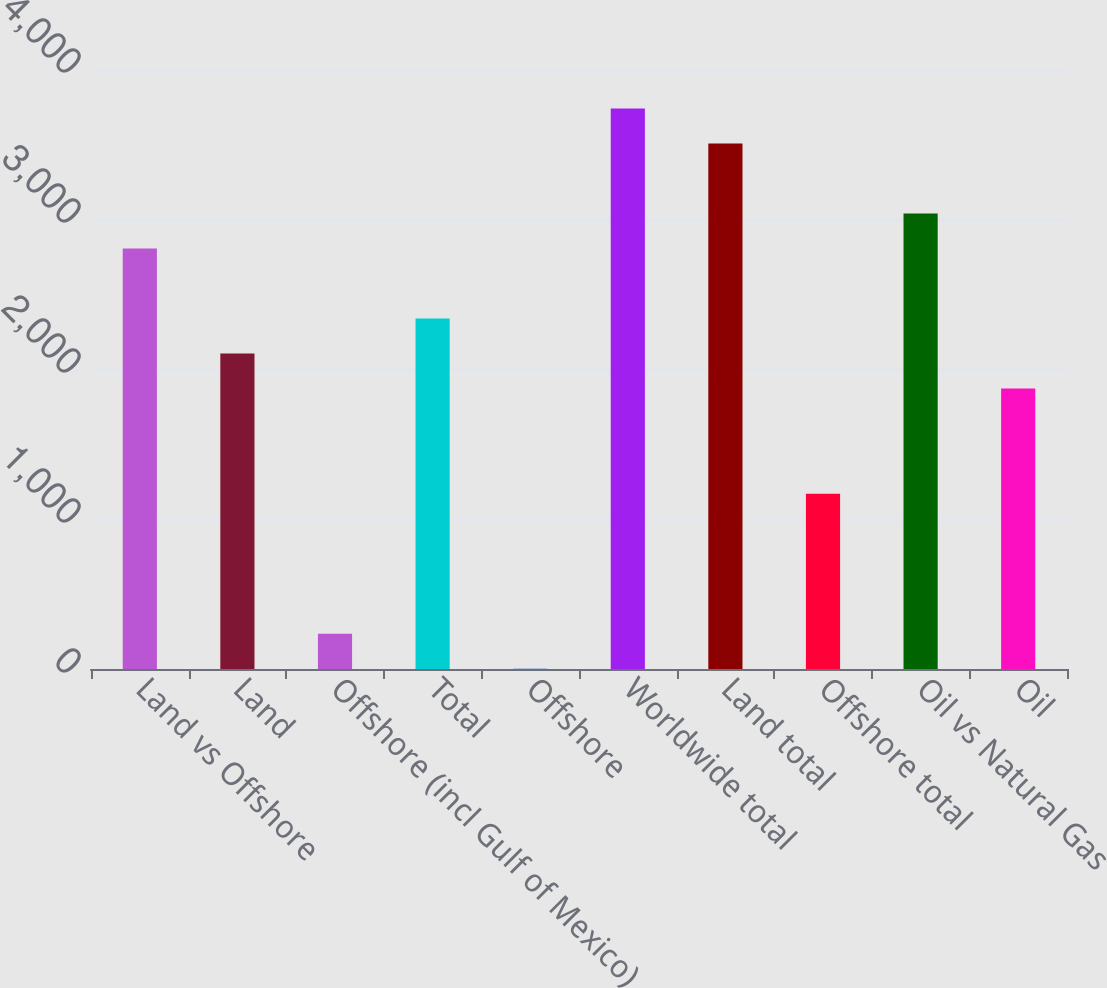Convert chart to OTSL. <chart><loc_0><loc_0><loc_500><loc_500><bar_chart><fcel>Land vs Offshore<fcel>Land<fcel>Offshore (incl Gulf of Mexico)<fcel>Total<fcel>Offshore<fcel>Worldwide total<fcel>Land total<fcel>Offshore total<fcel>Oil vs Natural Gas<fcel>Oil<nl><fcel>2802.8<fcel>2102.6<fcel>235.4<fcel>2336<fcel>2<fcel>3736.4<fcel>3503<fcel>1169<fcel>3036.2<fcel>1869.2<nl></chart> 